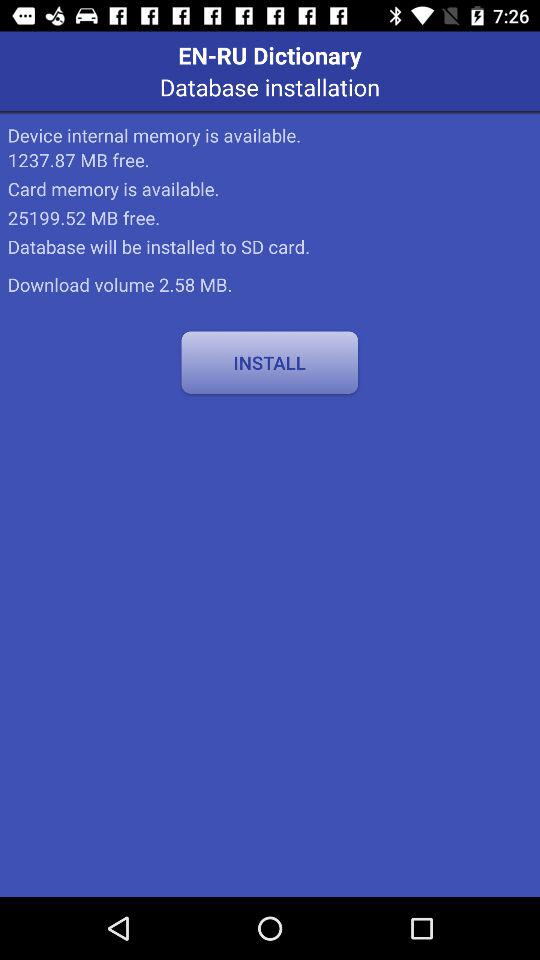On which card database will be installed? A database will be installed on the SD card. 